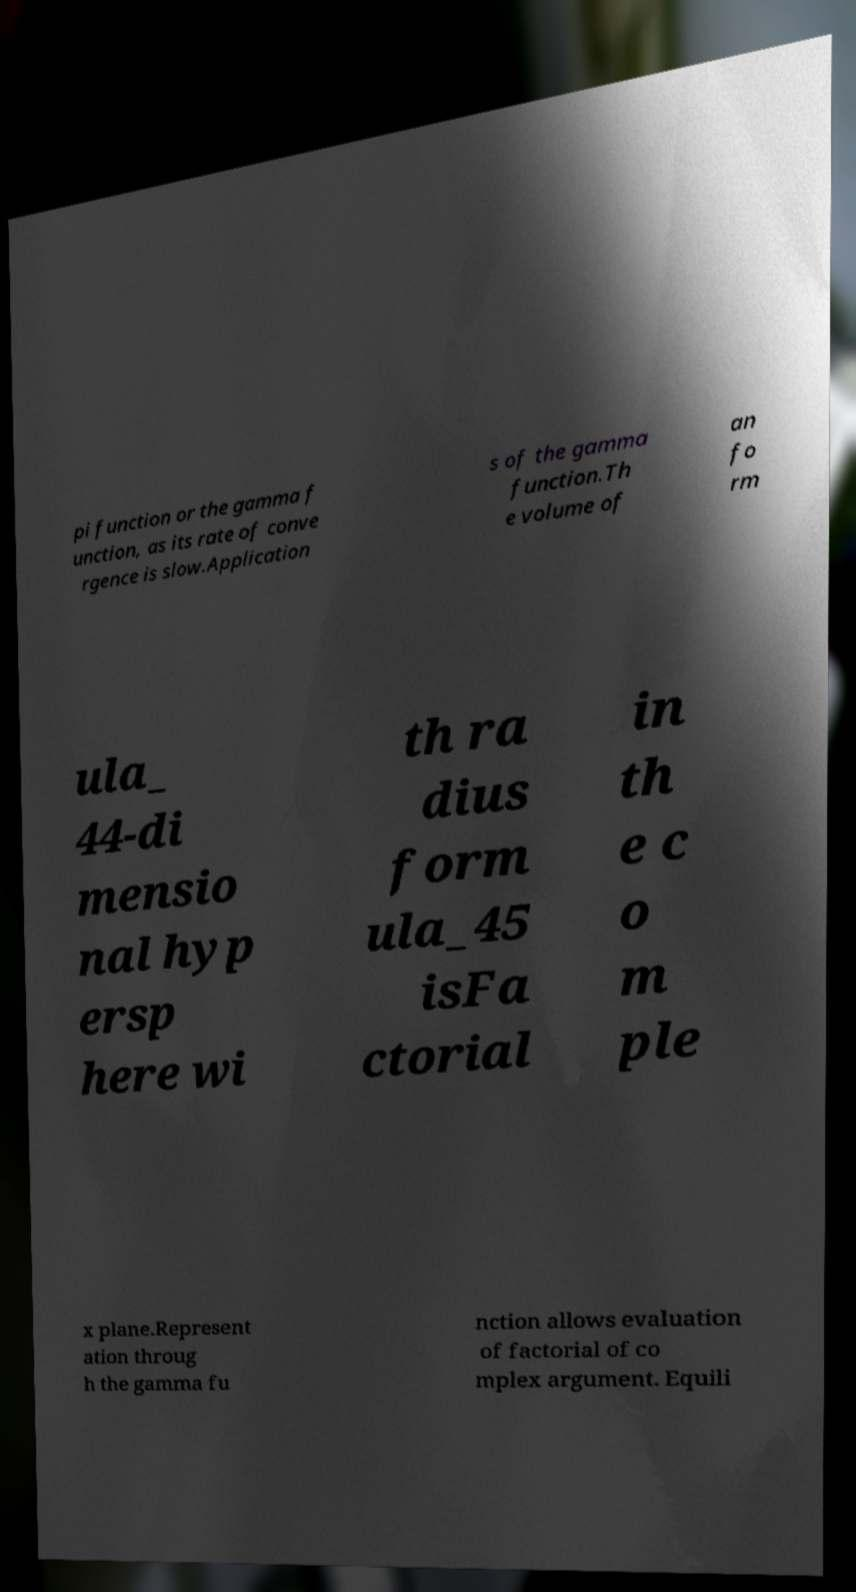There's text embedded in this image that I need extracted. Can you transcribe it verbatim? pi function or the gamma f unction, as its rate of conve rgence is slow.Application s of the gamma function.Th e volume of an fo rm ula_ 44-di mensio nal hyp ersp here wi th ra dius form ula_45 isFa ctorial in th e c o m ple x plane.Represent ation throug h the gamma fu nction allows evaluation of factorial of co mplex argument. Equili 